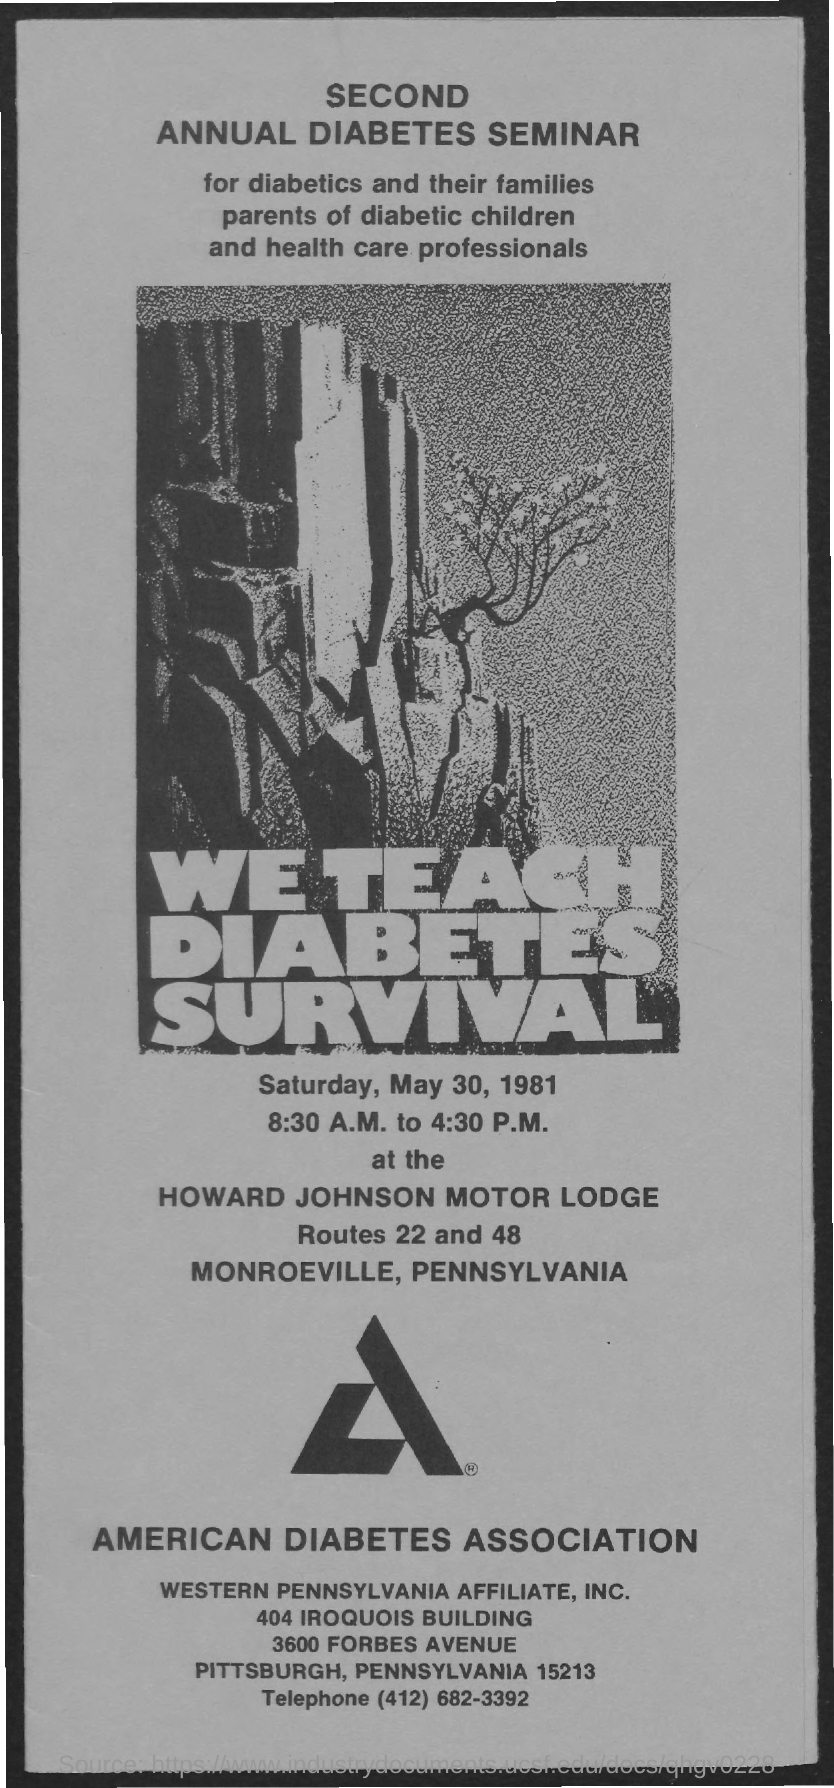When is the Seminar?
Your response must be concise. SATURDAY, MAY 30, 1981. 